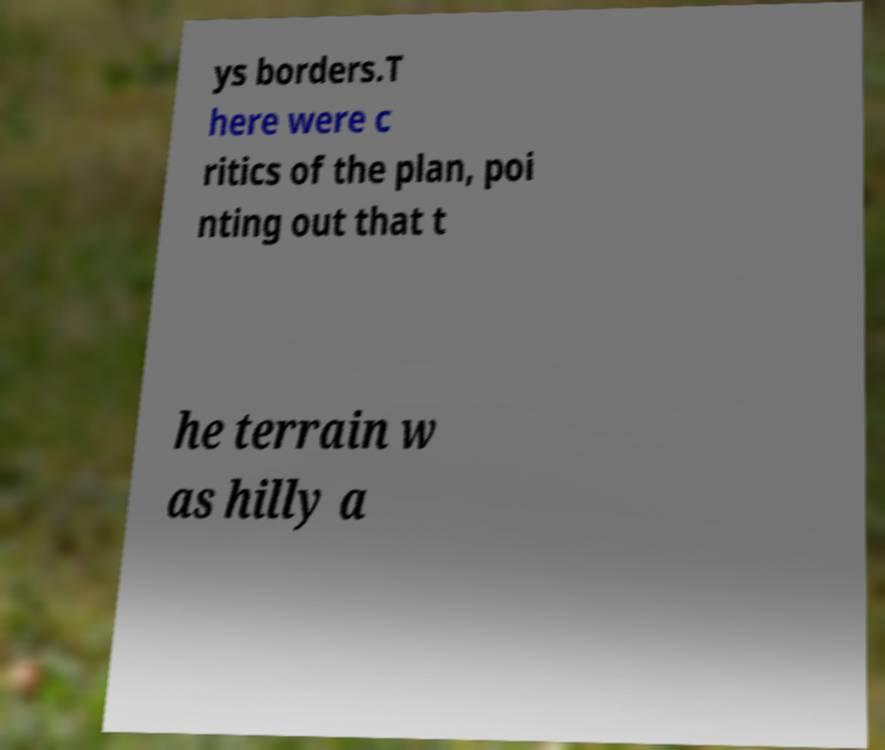What messages or text are displayed in this image? I need them in a readable, typed format. ys borders.T here were c ritics of the plan, poi nting out that t he terrain w as hilly a 